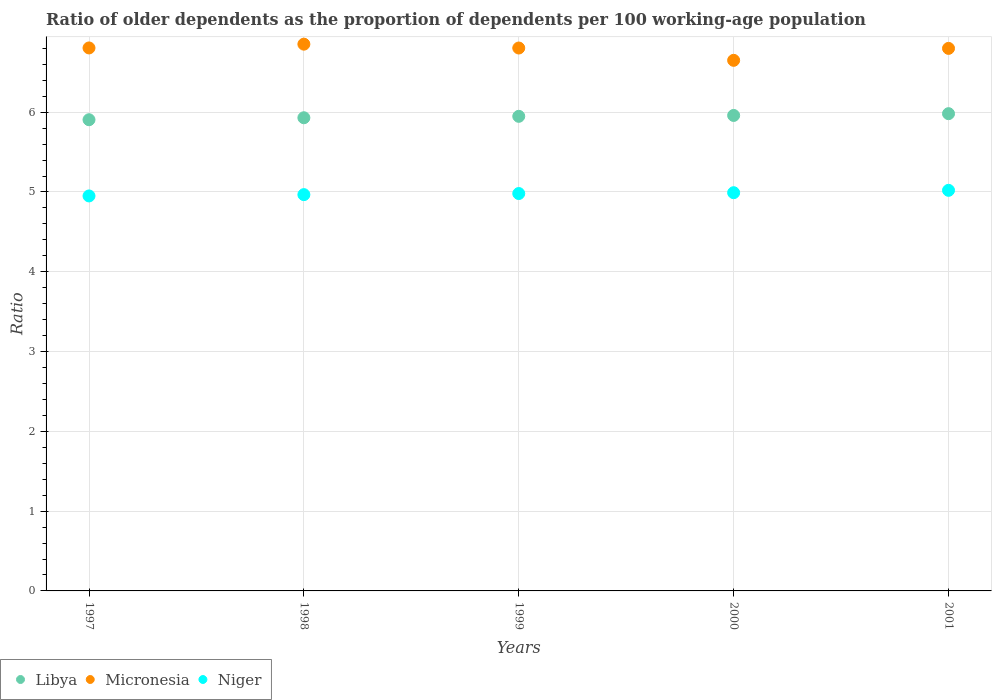How many different coloured dotlines are there?
Give a very brief answer. 3. What is the age dependency ratio(old) in Niger in 1997?
Your response must be concise. 4.95. Across all years, what is the maximum age dependency ratio(old) in Micronesia?
Make the answer very short. 6.85. Across all years, what is the minimum age dependency ratio(old) in Micronesia?
Keep it short and to the point. 6.65. In which year was the age dependency ratio(old) in Niger minimum?
Offer a very short reply. 1997. What is the total age dependency ratio(old) in Niger in the graph?
Your answer should be compact. 24.91. What is the difference between the age dependency ratio(old) in Libya in 1998 and that in 1999?
Offer a very short reply. -0.02. What is the difference between the age dependency ratio(old) in Micronesia in 1998 and the age dependency ratio(old) in Niger in 1997?
Provide a succinct answer. 1.9. What is the average age dependency ratio(old) in Niger per year?
Provide a succinct answer. 4.98. In the year 2001, what is the difference between the age dependency ratio(old) in Micronesia and age dependency ratio(old) in Libya?
Offer a terse response. 0.82. What is the ratio of the age dependency ratio(old) in Niger in 1997 to that in 2000?
Provide a succinct answer. 0.99. What is the difference between the highest and the second highest age dependency ratio(old) in Niger?
Ensure brevity in your answer.  0.03. What is the difference between the highest and the lowest age dependency ratio(old) in Libya?
Ensure brevity in your answer.  0.08. In how many years, is the age dependency ratio(old) in Niger greater than the average age dependency ratio(old) in Niger taken over all years?
Ensure brevity in your answer.  2. Is the sum of the age dependency ratio(old) in Niger in 1998 and 1999 greater than the maximum age dependency ratio(old) in Micronesia across all years?
Your answer should be compact. Yes. Is it the case that in every year, the sum of the age dependency ratio(old) in Niger and age dependency ratio(old) in Micronesia  is greater than the age dependency ratio(old) in Libya?
Your answer should be compact. Yes. Is the age dependency ratio(old) in Libya strictly greater than the age dependency ratio(old) in Niger over the years?
Make the answer very short. Yes. Is the age dependency ratio(old) in Niger strictly less than the age dependency ratio(old) in Libya over the years?
Give a very brief answer. Yes. How many dotlines are there?
Give a very brief answer. 3. How many legend labels are there?
Make the answer very short. 3. How are the legend labels stacked?
Ensure brevity in your answer.  Horizontal. What is the title of the graph?
Offer a terse response. Ratio of older dependents as the proportion of dependents per 100 working-age population. What is the label or title of the X-axis?
Your response must be concise. Years. What is the label or title of the Y-axis?
Provide a succinct answer. Ratio. What is the Ratio in Libya in 1997?
Provide a short and direct response. 5.91. What is the Ratio in Micronesia in 1997?
Offer a terse response. 6.81. What is the Ratio in Niger in 1997?
Keep it short and to the point. 4.95. What is the Ratio of Libya in 1998?
Give a very brief answer. 5.93. What is the Ratio in Micronesia in 1998?
Make the answer very short. 6.85. What is the Ratio in Niger in 1998?
Ensure brevity in your answer.  4.97. What is the Ratio in Libya in 1999?
Ensure brevity in your answer.  5.95. What is the Ratio of Micronesia in 1999?
Keep it short and to the point. 6.8. What is the Ratio of Niger in 1999?
Make the answer very short. 4.98. What is the Ratio in Libya in 2000?
Give a very brief answer. 5.96. What is the Ratio of Micronesia in 2000?
Offer a very short reply. 6.65. What is the Ratio of Niger in 2000?
Offer a very short reply. 4.99. What is the Ratio in Libya in 2001?
Keep it short and to the point. 5.98. What is the Ratio in Micronesia in 2001?
Keep it short and to the point. 6.8. What is the Ratio in Niger in 2001?
Your answer should be compact. 5.02. Across all years, what is the maximum Ratio of Libya?
Provide a succinct answer. 5.98. Across all years, what is the maximum Ratio in Micronesia?
Make the answer very short. 6.85. Across all years, what is the maximum Ratio of Niger?
Your answer should be compact. 5.02. Across all years, what is the minimum Ratio in Libya?
Give a very brief answer. 5.91. Across all years, what is the minimum Ratio of Micronesia?
Your response must be concise. 6.65. Across all years, what is the minimum Ratio in Niger?
Give a very brief answer. 4.95. What is the total Ratio in Libya in the graph?
Provide a succinct answer. 29.73. What is the total Ratio of Micronesia in the graph?
Provide a short and direct response. 33.91. What is the total Ratio in Niger in the graph?
Make the answer very short. 24.91. What is the difference between the Ratio in Libya in 1997 and that in 1998?
Give a very brief answer. -0.02. What is the difference between the Ratio of Micronesia in 1997 and that in 1998?
Keep it short and to the point. -0.05. What is the difference between the Ratio of Niger in 1997 and that in 1998?
Your answer should be very brief. -0.02. What is the difference between the Ratio in Libya in 1997 and that in 1999?
Make the answer very short. -0.04. What is the difference between the Ratio in Niger in 1997 and that in 1999?
Your response must be concise. -0.03. What is the difference between the Ratio in Libya in 1997 and that in 2000?
Provide a succinct answer. -0.05. What is the difference between the Ratio in Micronesia in 1997 and that in 2000?
Provide a succinct answer. 0.16. What is the difference between the Ratio in Niger in 1997 and that in 2000?
Provide a short and direct response. -0.04. What is the difference between the Ratio in Libya in 1997 and that in 2001?
Ensure brevity in your answer.  -0.08. What is the difference between the Ratio of Micronesia in 1997 and that in 2001?
Give a very brief answer. 0.01. What is the difference between the Ratio in Niger in 1997 and that in 2001?
Make the answer very short. -0.07. What is the difference between the Ratio in Libya in 1998 and that in 1999?
Give a very brief answer. -0.02. What is the difference between the Ratio in Micronesia in 1998 and that in 1999?
Your answer should be compact. 0.05. What is the difference between the Ratio of Niger in 1998 and that in 1999?
Your answer should be compact. -0.01. What is the difference between the Ratio in Libya in 1998 and that in 2000?
Provide a short and direct response. -0.03. What is the difference between the Ratio in Micronesia in 1998 and that in 2000?
Offer a very short reply. 0.2. What is the difference between the Ratio of Niger in 1998 and that in 2000?
Make the answer very short. -0.02. What is the difference between the Ratio of Libya in 1998 and that in 2001?
Keep it short and to the point. -0.05. What is the difference between the Ratio in Micronesia in 1998 and that in 2001?
Offer a very short reply. 0.05. What is the difference between the Ratio of Niger in 1998 and that in 2001?
Provide a short and direct response. -0.05. What is the difference between the Ratio of Libya in 1999 and that in 2000?
Your response must be concise. -0.01. What is the difference between the Ratio of Micronesia in 1999 and that in 2000?
Provide a succinct answer. 0.15. What is the difference between the Ratio of Niger in 1999 and that in 2000?
Provide a short and direct response. -0.01. What is the difference between the Ratio of Libya in 1999 and that in 2001?
Give a very brief answer. -0.03. What is the difference between the Ratio in Micronesia in 1999 and that in 2001?
Your response must be concise. 0. What is the difference between the Ratio of Niger in 1999 and that in 2001?
Give a very brief answer. -0.04. What is the difference between the Ratio in Libya in 2000 and that in 2001?
Offer a terse response. -0.02. What is the difference between the Ratio in Micronesia in 2000 and that in 2001?
Make the answer very short. -0.15. What is the difference between the Ratio in Niger in 2000 and that in 2001?
Provide a succinct answer. -0.03. What is the difference between the Ratio of Libya in 1997 and the Ratio of Micronesia in 1998?
Ensure brevity in your answer.  -0.95. What is the difference between the Ratio of Libya in 1997 and the Ratio of Niger in 1998?
Provide a short and direct response. 0.94. What is the difference between the Ratio in Micronesia in 1997 and the Ratio in Niger in 1998?
Make the answer very short. 1.84. What is the difference between the Ratio of Libya in 1997 and the Ratio of Micronesia in 1999?
Your answer should be compact. -0.9. What is the difference between the Ratio in Libya in 1997 and the Ratio in Niger in 1999?
Your answer should be compact. 0.93. What is the difference between the Ratio of Micronesia in 1997 and the Ratio of Niger in 1999?
Keep it short and to the point. 1.82. What is the difference between the Ratio of Libya in 1997 and the Ratio of Micronesia in 2000?
Your answer should be very brief. -0.74. What is the difference between the Ratio of Libya in 1997 and the Ratio of Niger in 2000?
Ensure brevity in your answer.  0.91. What is the difference between the Ratio in Micronesia in 1997 and the Ratio in Niger in 2000?
Make the answer very short. 1.81. What is the difference between the Ratio in Libya in 1997 and the Ratio in Micronesia in 2001?
Your response must be concise. -0.89. What is the difference between the Ratio of Libya in 1997 and the Ratio of Niger in 2001?
Give a very brief answer. 0.88. What is the difference between the Ratio in Micronesia in 1997 and the Ratio in Niger in 2001?
Your answer should be compact. 1.78. What is the difference between the Ratio in Libya in 1998 and the Ratio in Micronesia in 1999?
Offer a terse response. -0.87. What is the difference between the Ratio in Libya in 1998 and the Ratio in Niger in 1999?
Offer a terse response. 0.95. What is the difference between the Ratio of Micronesia in 1998 and the Ratio of Niger in 1999?
Offer a terse response. 1.87. What is the difference between the Ratio of Libya in 1998 and the Ratio of Micronesia in 2000?
Keep it short and to the point. -0.72. What is the difference between the Ratio of Libya in 1998 and the Ratio of Niger in 2000?
Keep it short and to the point. 0.94. What is the difference between the Ratio in Micronesia in 1998 and the Ratio in Niger in 2000?
Make the answer very short. 1.86. What is the difference between the Ratio in Libya in 1998 and the Ratio in Micronesia in 2001?
Your answer should be compact. -0.87. What is the difference between the Ratio in Libya in 1998 and the Ratio in Niger in 2001?
Your answer should be very brief. 0.91. What is the difference between the Ratio of Micronesia in 1998 and the Ratio of Niger in 2001?
Offer a terse response. 1.83. What is the difference between the Ratio in Libya in 1999 and the Ratio in Micronesia in 2000?
Your response must be concise. -0.7. What is the difference between the Ratio in Libya in 1999 and the Ratio in Niger in 2000?
Your answer should be very brief. 0.96. What is the difference between the Ratio in Micronesia in 1999 and the Ratio in Niger in 2000?
Provide a short and direct response. 1.81. What is the difference between the Ratio in Libya in 1999 and the Ratio in Micronesia in 2001?
Your response must be concise. -0.85. What is the difference between the Ratio in Libya in 1999 and the Ratio in Niger in 2001?
Make the answer very short. 0.93. What is the difference between the Ratio in Micronesia in 1999 and the Ratio in Niger in 2001?
Ensure brevity in your answer.  1.78. What is the difference between the Ratio in Libya in 2000 and the Ratio in Micronesia in 2001?
Offer a terse response. -0.84. What is the difference between the Ratio of Libya in 2000 and the Ratio of Niger in 2001?
Your response must be concise. 0.94. What is the difference between the Ratio of Micronesia in 2000 and the Ratio of Niger in 2001?
Provide a short and direct response. 1.63. What is the average Ratio of Libya per year?
Ensure brevity in your answer.  5.95. What is the average Ratio in Micronesia per year?
Make the answer very short. 6.78. What is the average Ratio of Niger per year?
Ensure brevity in your answer.  4.98. In the year 1997, what is the difference between the Ratio of Libya and Ratio of Micronesia?
Make the answer very short. -0.9. In the year 1997, what is the difference between the Ratio of Libya and Ratio of Niger?
Your answer should be compact. 0.96. In the year 1997, what is the difference between the Ratio of Micronesia and Ratio of Niger?
Your answer should be compact. 1.85. In the year 1998, what is the difference between the Ratio in Libya and Ratio in Micronesia?
Make the answer very short. -0.92. In the year 1998, what is the difference between the Ratio of Libya and Ratio of Niger?
Ensure brevity in your answer.  0.96. In the year 1998, what is the difference between the Ratio of Micronesia and Ratio of Niger?
Your response must be concise. 1.89. In the year 1999, what is the difference between the Ratio of Libya and Ratio of Micronesia?
Your answer should be compact. -0.86. In the year 1999, what is the difference between the Ratio of Libya and Ratio of Niger?
Make the answer very short. 0.97. In the year 1999, what is the difference between the Ratio in Micronesia and Ratio in Niger?
Your answer should be compact. 1.82. In the year 2000, what is the difference between the Ratio in Libya and Ratio in Micronesia?
Provide a short and direct response. -0.69. In the year 2000, what is the difference between the Ratio in Libya and Ratio in Niger?
Your answer should be very brief. 0.97. In the year 2000, what is the difference between the Ratio of Micronesia and Ratio of Niger?
Offer a terse response. 1.66. In the year 2001, what is the difference between the Ratio in Libya and Ratio in Micronesia?
Keep it short and to the point. -0.82. In the year 2001, what is the difference between the Ratio of Libya and Ratio of Niger?
Provide a short and direct response. 0.96. In the year 2001, what is the difference between the Ratio in Micronesia and Ratio in Niger?
Offer a very short reply. 1.78. What is the ratio of the Ratio in Micronesia in 1997 to that in 1998?
Ensure brevity in your answer.  0.99. What is the ratio of the Ratio in Micronesia in 1997 to that in 1999?
Keep it short and to the point. 1. What is the ratio of the Ratio in Niger in 1997 to that in 1999?
Your response must be concise. 0.99. What is the ratio of the Ratio in Micronesia in 1997 to that in 2000?
Your answer should be compact. 1.02. What is the ratio of the Ratio of Niger in 1997 to that in 2000?
Provide a succinct answer. 0.99. What is the ratio of the Ratio of Libya in 1997 to that in 2001?
Ensure brevity in your answer.  0.99. What is the ratio of the Ratio in Micronesia in 1997 to that in 2001?
Make the answer very short. 1. What is the ratio of the Ratio in Niger in 1997 to that in 2001?
Provide a succinct answer. 0.99. What is the ratio of the Ratio of Libya in 1998 to that in 1999?
Provide a short and direct response. 1. What is the ratio of the Ratio in Micronesia in 1998 to that in 1999?
Offer a terse response. 1.01. What is the ratio of the Ratio of Micronesia in 1998 to that in 2000?
Offer a terse response. 1.03. What is the ratio of the Ratio of Niger in 1998 to that in 2000?
Offer a terse response. 1. What is the ratio of the Ratio of Libya in 1998 to that in 2001?
Make the answer very short. 0.99. What is the ratio of the Ratio of Niger in 1998 to that in 2001?
Provide a short and direct response. 0.99. What is the ratio of the Ratio in Micronesia in 1999 to that in 2000?
Offer a terse response. 1.02. What is the ratio of the Ratio in Niger in 1999 to that in 2000?
Your response must be concise. 1. What is the ratio of the Ratio of Micronesia in 2000 to that in 2001?
Your response must be concise. 0.98. What is the difference between the highest and the second highest Ratio in Libya?
Make the answer very short. 0.02. What is the difference between the highest and the second highest Ratio in Micronesia?
Ensure brevity in your answer.  0.05. What is the difference between the highest and the second highest Ratio in Niger?
Your answer should be very brief. 0.03. What is the difference between the highest and the lowest Ratio in Libya?
Your response must be concise. 0.08. What is the difference between the highest and the lowest Ratio of Micronesia?
Ensure brevity in your answer.  0.2. What is the difference between the highest and the lowest Ratio of Niger?
Give a very brief answer. 0.07. 